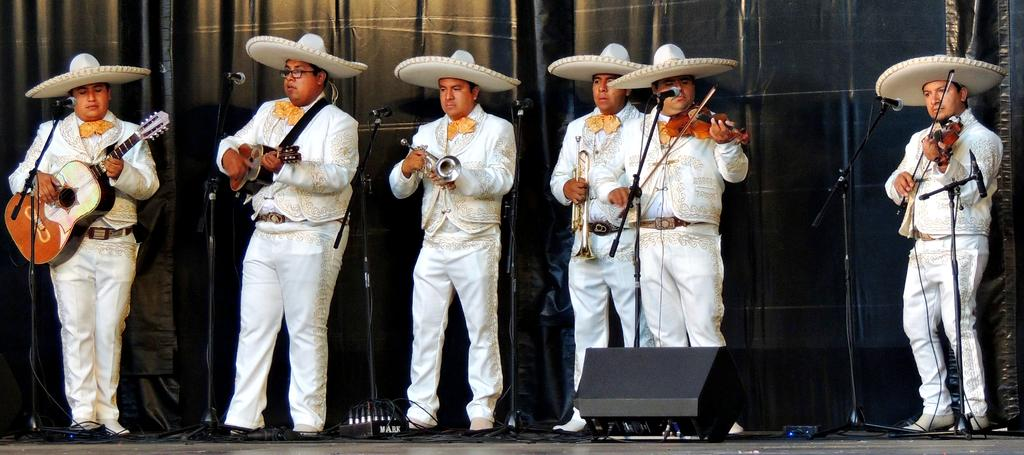How many people are in the image? There are six men in the image. What are the men doing in the image? The men are standing and playing musical instruments. What object is in front of the men? There is a microphone in front of the men. What can be seen in the background of the image? There is a curtain in the background of the image. What type of needle is being used by the spy in the image? There is no spy or needle present in the image. The image features six men playing musical instruments. 